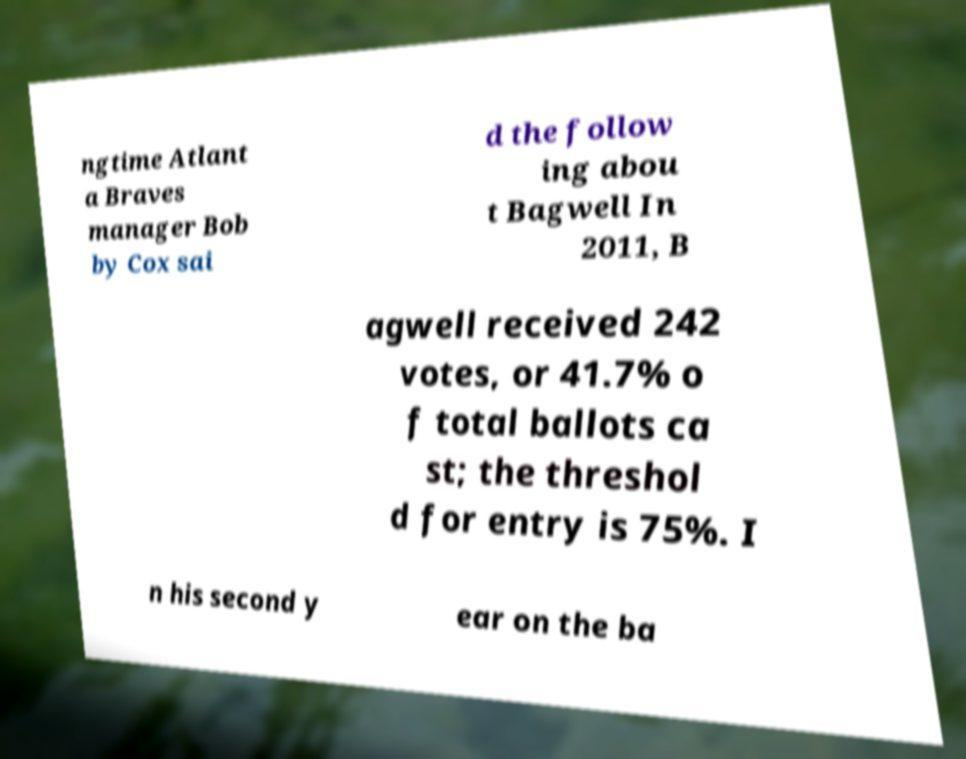Can you read and provide the text displayed in the image?This photo seems to have some interesting text. Can you extract and type it out for me? ngtime Atlant a Braves manager Bob by Cox sai d the follow ing abou t Bagwell In 2011, B agwell received 242 votes, or 41.7% o f total ballots ca st; the threshol d for entry is 75%. I n his second y ear on the ba 